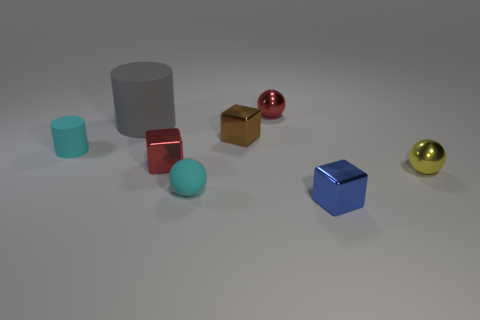What is the color of the other metallic sphere that is the same size as the yellow sphere?
Offer a very short reply. Red. Does the tiny cylinder have the same material as the small cyan ball?
Keep it short and to the point. Yes. What number of things are the same color as the small matte ball?
Your answer should be very brief. 1. Is the color of the tiny rubber cylinder the same as the tiny rubber ball?
Ensure brevity in your answer.  Yes. There is a block right of the red ball; what is its material?
Offer a terse response. Metal. How many small things are red spheres or metallic cubes?
Make the answer very short. 4. Is there a brown thing made of the same material as the blue cube?
Provide a succinct answer. Yes. There is a cyan matte thing behind the yellow metal object; does it have the same size as the tiny brown cube?
Your answer should be compact. Yes. Are there any blue objects that are to the right of the tiny cyan sphere on the left side of the shiny ball behind the tiny yellow shiny object?
Your answer should be very brief. Yes. What number of shiny things are small blue things or tiny purple balls?
Ensure brevity in your answer.  1. 